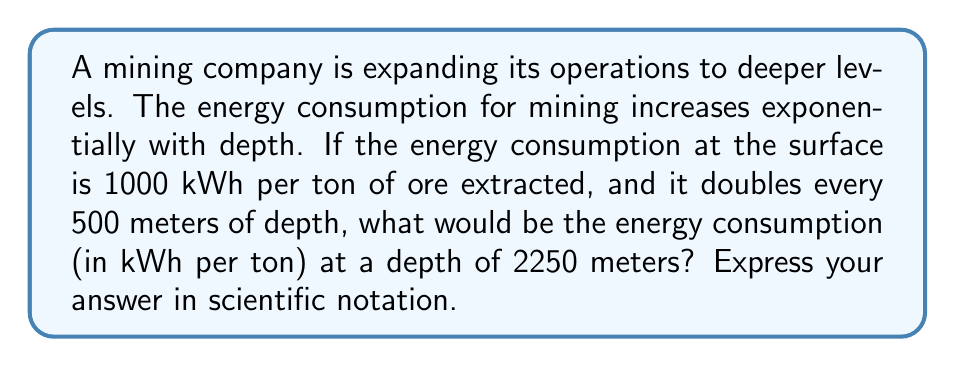Teach me how to tackle this problem. To solve this problem, we need to use the properties of exponential growth. Let's break it down step-by-step:

1) First, let's identify the key information:
   - Initial energy consumption: 1000 kWh/ton
   - Energy consumption doubles every 500 meters
   - Target depth: 2250 meters

2) We can express this as an exponential function:
   $$ E(d) = 1000 \cdot 2^{\frac{d}{500}} $$
   Where $E(d)$ is the energy consumption at depth $d$ in meters.

3) Now, let's substitute our target depth:
   $$ E(2250) = 1000 \cdot 2^{\frac{2250}{500}} $$

4) Simplify the exponent:
   $$ E(2250) = 1000 \cdot 2^{4.5} $$

5) Calculate $2^{4.5}$:
   $2^{4.5} = 2^4 \cdot 2^{0.5} \approx 16 \cdot 1.4142 \approx 22.6274$

6) Multiply by 1000:
   $$ E(2250) = 1000 \cdot 22.6274 = 22,627.4 \text{ kWh/ton} $$

7) Express in scientific notation:
   $$ E(2250) = 2.26274 \times 10^4 \text{ kWh/ton} $$
Answer: $2.26 \times 10^4 \text{ kWh/ton}$ 